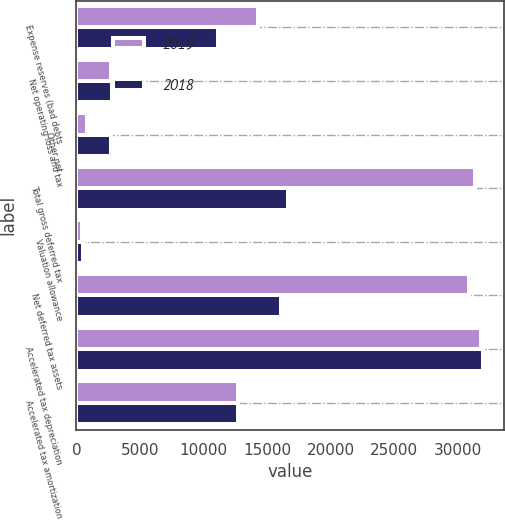Convert chart to OTSL. <chart><loc_0><loc_0><loc_500><loc_500><stacked_bar_chart><ecel><fcel>Expense reserves (bad debts<fcel>Net operating loss and tax<fcel>Other net<fcel>Total gross deferred tax<fcel>Valuation allowance<fcel>Net deferred tax assets<fcel>Accelerated tax depreciation<fcel>Accelerated tax amortization<nl><fcel>2019<fcel>14325<fcel>2713<fcel>851<fcel>31339<fcel>415<fcel>30924<fcel>31846<fcel>12744.5<nl><fcel>2018<fcel>11164<fcel>2759<fcel>2711<fcel>16634<fcel>515<fcel>16119<fcel>32026<fcel>12744.5<nl></chart> 